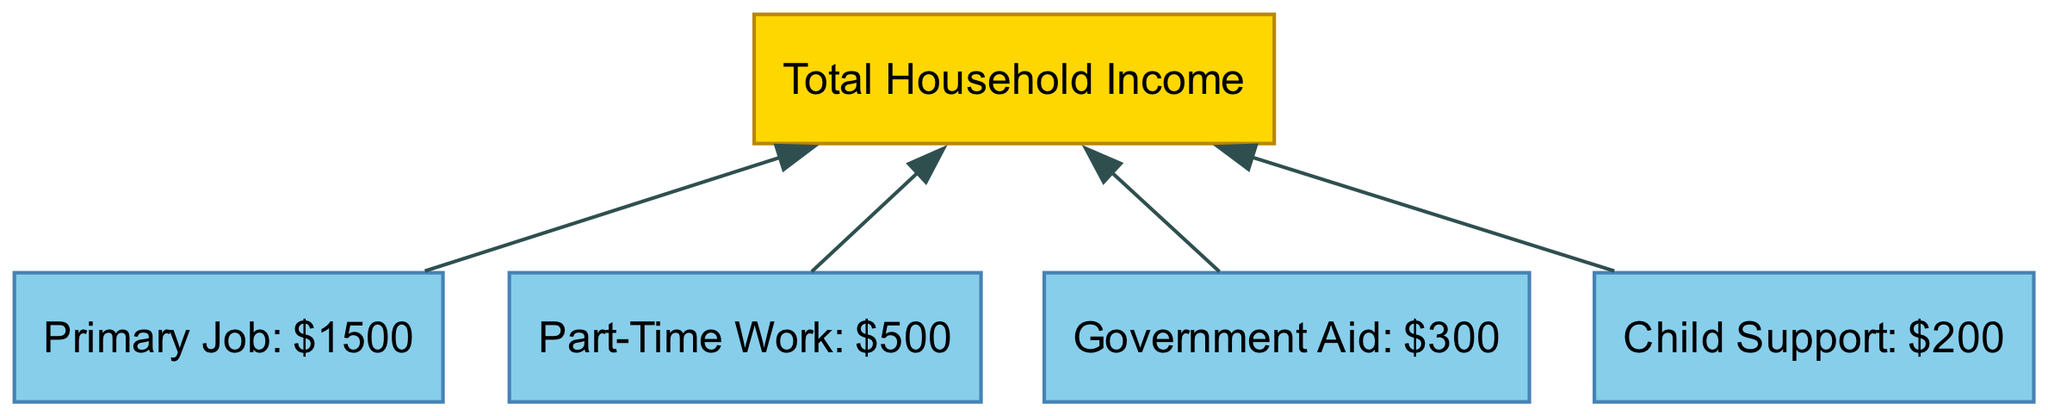What is the total household income shown in the diagram? The diagram identifies the total household income as the starting point and does not assign a specific dollar amount. Instead, the income sources below it contribute to this total. However, if we look at the individual income sources, we can calculate it as $1500 + $500 + $300 + $200, which equals $2500.
Answer: $2500 How much does the primary job contribute to the total household income? The diagram specifically states that the primary job contributes $1500 to the total household income. This is indicated directly in its node label.
Answer: $1500 What are the individual income sources listed in the diagram? The diagram includes four income sources: primary job, part-time work, government aid, and child support. Each of these is represented in its own node.
Answer: Primary job, part-time work, government aid, child support Which income source has the smallest contribution? By comparing the income contributions in the diagram, the smallest contribution is from government aid at $300. This is clearly stated in its node label.
Answer: $300 What is the total contribution from part-time work and child support combined? The part-time work contributes $500 and child support contributes $200 as per the respective node labels. Adding these two amounts together (500 + 200), gives a total contribution of $700.
Answer: $700 How many total income sources are shown in the diagram? The diagram lists four income sources: primary job, part-time work, government aid, and child support. Counting the nodes reveals that there are four distinct income streams illustrated.
Answer: 4 What is the relationship between total household income and individual income sources? The diagram shows a hierarchical structure where the total household income is at the top, while individual income sources branch out below it, indicating that each source contributes to the total. This parent-child relationship is visually depicted through the links connecting the nodes.
Answer: Parent-child relationship Which income source contributes more, primary job or government aid? The primary job contributes $1500 while government aid contributes $300. By comparing these amounts directly, we see that the primary job has a significantly higher contribution to the total household income than government aid.
Answer: Primary job 